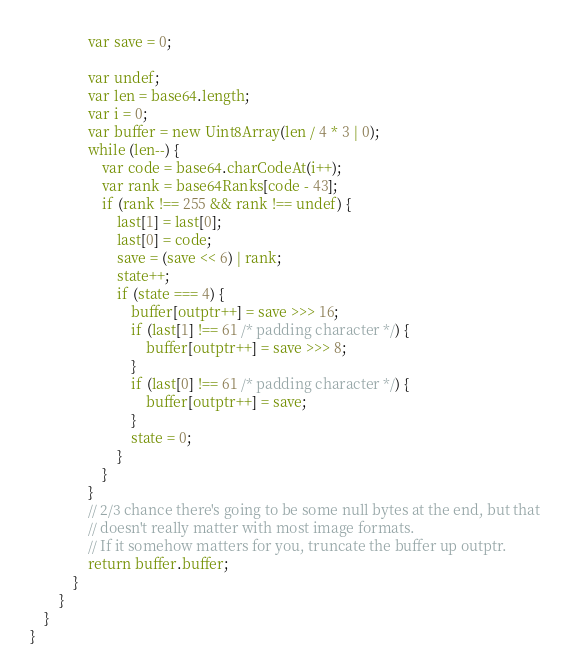<code> <loc_0><loc_0><loc_500><loc_500><_TypeScript_>                var save = 0;

                var undef;
                var len = base64.length;
                var i = 0;
                var buffer = new Uint8Array(len / 4 * 3 | 0);
                while (len--) {
                    var code = base64.charCodeAt(i++);
                    var rank = base64Ranks[code - 43];
                    if (rank !== 255 && rank !== undef) {
                        last[1] = last[0];
                        last[0] = code;
                        save = (save << 6) | rank;
                        state++;
                        if (state === 4) {
                            buffer[outptr++] = save >>> 16;
                            if (last[1] !== 61 /* padding character */) {
                                buffer[outptr++] = save >>> 8;
                            }
                            if (last[0] !== 61 /* padding character */) {
                                buffer[outptr++] = save;
                            }
                            state = 0;
                        }
                    }
                }
                // 2/3 chance there's going to be some null bytes at the end, but that
                // doesn't really matter with most image formats.
                // If it somehow matters for you, truncate the buffer up outptr.
                return buffer.buffer;
            }
        }
    }
}</code> 